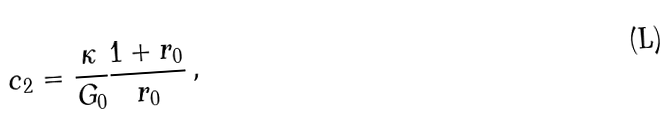Convert formula to latex. <formula><loc_0><loc_0><loc_500><loc_500>c _ { 2 } = \frac { \kappa } { G _ { 0 } } \frac { 1 + r _ { 0 } } { r _ { 0 } } \, ,</formula> 